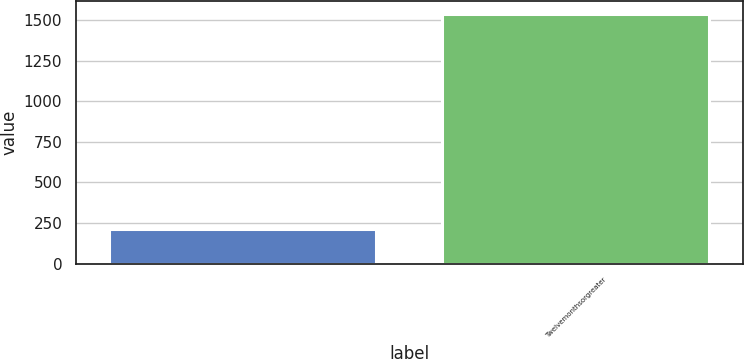Convert chart to OTSL. <chart><loc_0><loc_0><loc_500><loc_500><bar_chart><ecel><fcel>Twelvemonthsorgreater<nl><fcel>211<fcel>1537<nl></chart> 